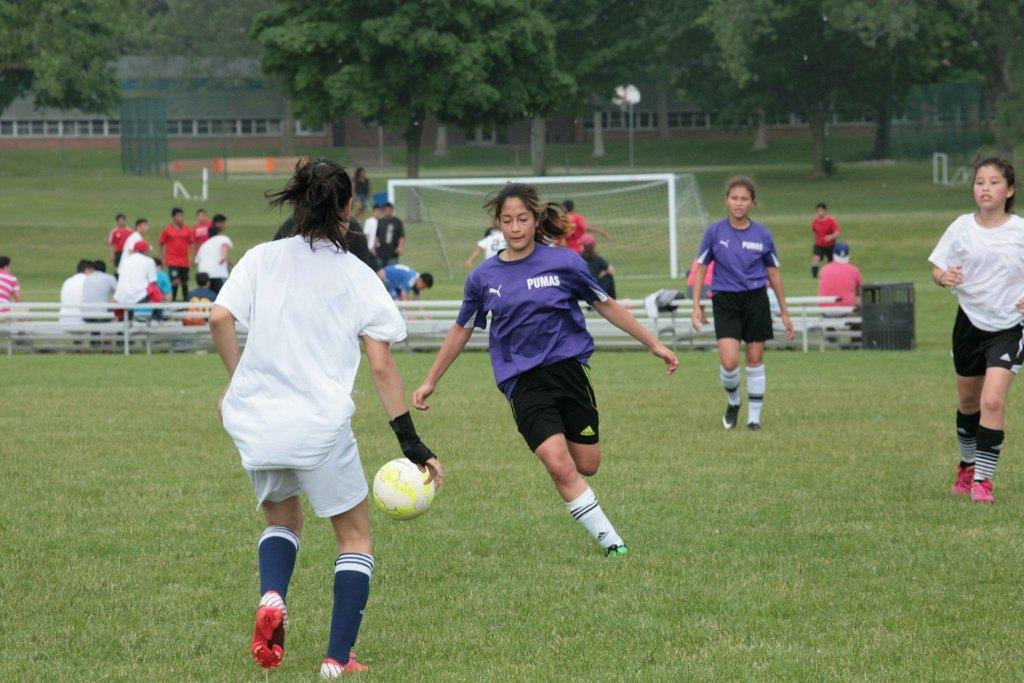<image>
Render a clear and concise summary of the photo. the purple soccer team is wearing PUMAS jersey 